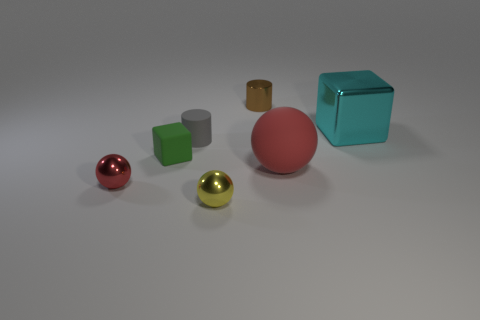Is the number of small metal spheres that are behind the tiny matte cube less than the number of small metallic objects that are behind the tiny red metallic object? The image shows a collection of objects, including spheres and cubes of various sizes and materials. After carefully analyzing the positions and materials of the objects in question, it appears that there are indeed fewer small metal spheres located behind the tiny matte cube than small metallic objects behind the tiny red metallic object. 